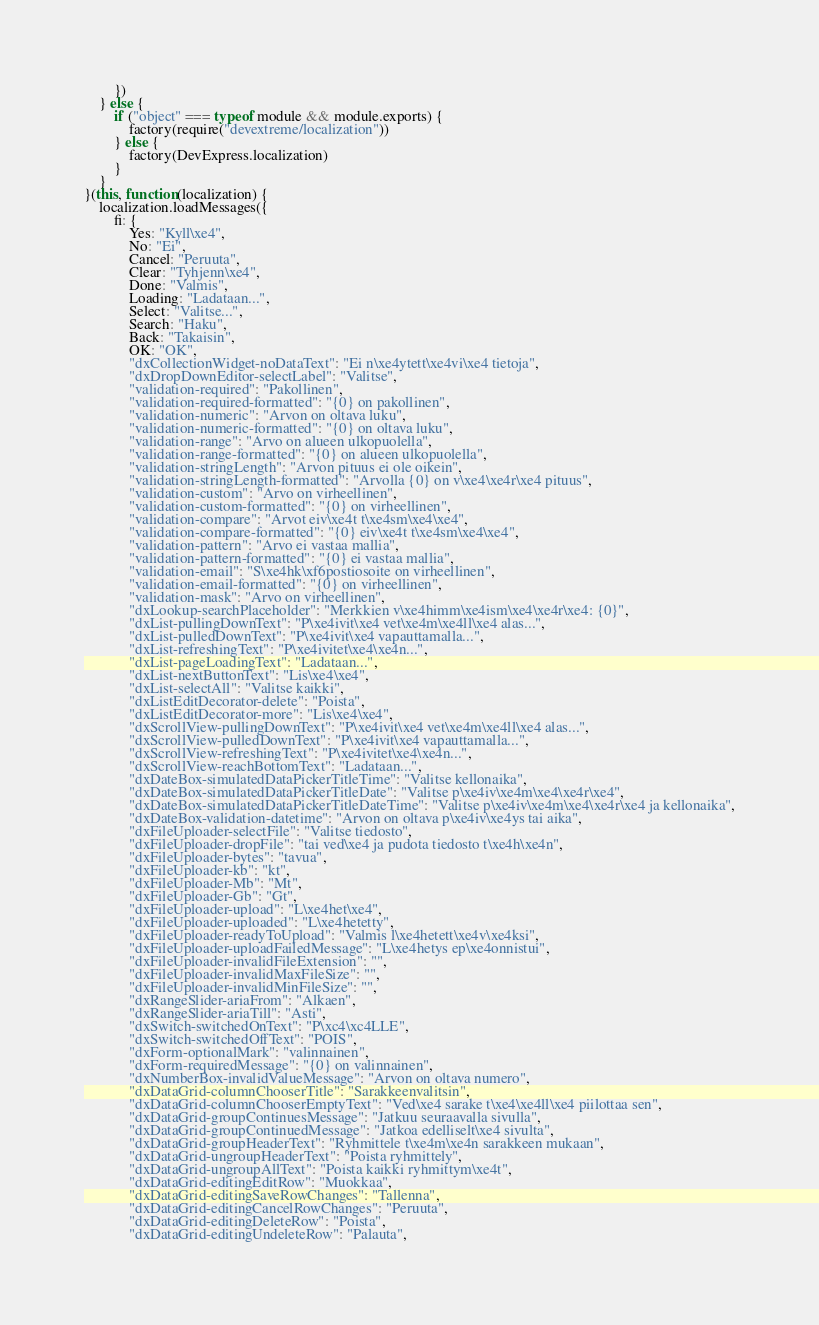Convert code to text. <code><loc_0><loc_0><loc_500><loc_500><_JavaScript_>        })
    } else {
        if ("object" === typeof module && module.exports) {
            factory(require("devextreme/localization"))
        } else {
            factory(DevExpress.localization)
        }
    }
}(this, function(localization) {
    localization.loadMessages({
        fi: {
            Yes: "Kyll\xe4",
            No: "Ei",
            Cancel: "Peruuta",
            Clear: "Tyhjenn\xe4",
            Done: "Valmis",
            Loading: "Ladataan...",
            Select: "Valitse...",
            Search: "Haku",
            Back: "Takaisin",
            OK: "OK",
            "dxCollectionWidget-noDataText": "Ei n\xe4ytett\xe4vi\xe4 tietoja",
            "dxDropDownEditor-selectLabel": "Valitse",
            "validation-required": "Pakollinen",
            "validation-required-formatted": "{0} on pakollinen",
            "validation-numeric": "Arvon on oltava luku",
            "validation-numeric-formatted": "{0} on oltava luku",
            "validation-range": "Arvo on alueen ulkopuolella",
            "validation-range-formatted": "{0} on alueen ulkopuolella",
            "validation-stringLength": "Arvon pituus ei ole oikein",
            "validation-stringLength-formatted": "Arvolla {0} on v\xe4\xe4r\xe4 pituus",
            "validation-custom": "Arvo on virheellinen",
            "validation-custom-formatted": "{0} on virheellinen",
            "validation-compare": "Arvot eiv\xe4t t\xe4sm\xe4\xe4",
            "validation-compare-formatted": "{0} eiv\xe4t t\xe4sm\xe4\xe4",
            "validation-pattern": "Arvo ei vastaa mallia",
            "validation-pattern-formatted": "{0} ei vastaa mallia",
            "validation-email": "S\xe4hk\xf6postiosoite on virheellinen",
            "validation-email-formatted": "{0} on virheellinen",
            "validation-mask": "Arvo on virheellinen",
            "dxLookup-searchPlaceholder": "Merkkien v\xe4himm\xe4ism\xe4\xe4r\xe4: {0}",
            "dxList-pullingDownText": "P\xe4ivit\xe4 vet\xe4m\xe4ll\xe4 alas...",
            "dxList-pulledDownText": "P\xe4ivit\xe4 vapauttamalla...",
            "dxList-refreshingText": "P\xe4ivitet\xe4\xe4n...",
            "dxList-pageLoadingText": "Ladataan...",
            "dxList-nextButtonText": "Lis\xe4\xe4",
            "dxList-selectAll": "Valitse kaikki",
            "dxListEditDecorator-delete": "Poista",
            "dxListEditDecorator-more": "Lis\xe4\xe4",
            "dxScrollView-pullingDownText": "P\xe4ivit\xe4 vet\xe4m\xe4ll\xe4 alas...",
            "dxScrollView-pulledDownText": "P\xe4ivit\xe4 vapauttamalla...",
            "dxScrollView-refreshingText": "P\xe4ivitet\xe4\xe4n...",
            "dxScrollView-reachBottomText": "Ladataan...",
            "dxDateBox-simulatedDataPickerTitleTime": "Valitse kellonaika",
            "dxDateBox-simulatedDataPickerTitleDate": "Valitse p\xe4iv\xe4m\xe4\xe4r\xe4",
            "dxDateBox-simulatedDataPickerTitleDateTime": "Valitse p\xe4iv\xe4m\xe4\xe4r\xe4 ja kellonaika",
            "dxDateBox-validation-datetime": "Arvon on oltava p\xe4iv\xe4ys tai aika",
            "dxFileUploader-selectFile": "Valitse tiedosto",
            "dxFileUploader-dropFile": "tai ved\xe4 ja pudota tiedosto t\xe4h\xe4n",
            "dxFileUploader-bytes": "tavua",
            "dxFileUploader-kb": "kt",
            "dxFileUploader-Mb": "Mt",
            "dxFileUploader-Gb": "Gt",
            "dxFileUploader-upload": "L\xe4het\xe4",
            "dxFileUploader-uploaded": "L\xe4hetetty",
            "dxFileUploader-readyToUpload": "Valmis l\xe4hetett\xe4v\xe4ksi",
            "dxFileUploader-uploadFailedMessage": "L\xe4hetys ep\xe4onnistui",
            "dxFileUploader-invalidFileExtension": "",
            "dxFileUploader-invalidMaxFileSize": "",
            "dxFileUploader-invalidMinFileSize": "",
            "dxRangeSlider-ariaFrom": "Alkaen",
            "dxRangeSlider-ariaTill": "Asti",
            "dxSwitch-switchedOnText": "P\xc4\xc4LLE",
            "dxSwitch-switchedOffText": "POIS",
            "dxForm-optionalMark": "valinnainen",
            "dxForm-requiredMessage": "{0} on valinnainen",
            "dxNumberBox-invalidValueMessage": "Arvon on oltava numero",
            "dxDataGrid-columnChooserTitle": "Sarakkeenvalitsin",
            "dxDataGrid-columnChooserEmptyText": "Ved\xe4 sarake t\xe4\xe4ll\xe4 piilottaa sen",
            "dxDataGrid-groupContinuesMessage": "Jatkuu seuraavalla sivulla",
            "dxDataGrid-groupContinuedMessage": "Jatkoa edelliselt\xe4 sivulta",
            "dxDataGrid-groupHeaderText": "Ryhmittele t\xe4m\xe4n sarakkeen mukaan",
            "dxDataGrid-ungroupHeaderText": "Poista ryhmittely",
            "dxDataGrid-ungroupAllText": "Poista kaikki ryhmittym\xe4t",
            "dxDataGrid-editingEditRow": "Muokkaa",
            "dxDataGrid-editingSaveRowChanges": "Tallenna",
            "dxDataGrid-editingCancelRowChanges": "Peruuta",
            "dxDataGrid-editingDeleteRow": "Poista",
            "dxDataGrid-editingUndeleteRow": "Palauta",</code> 